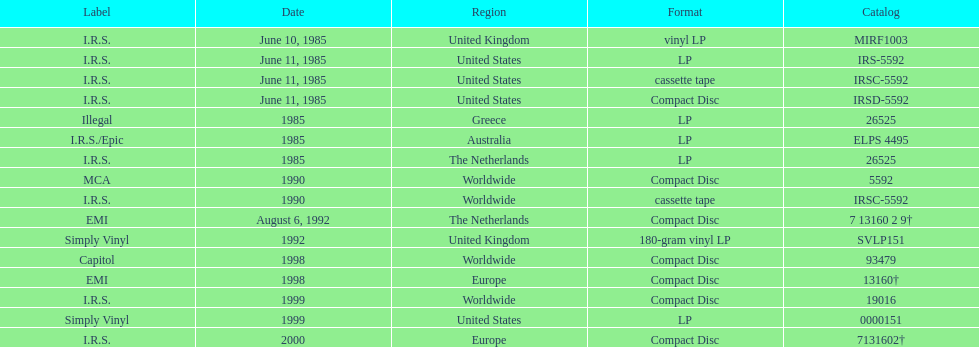How many more releases were in compact disc format than cassette tape? 5. 